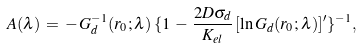<formula> <loc_0><loc_0><loc_500><loc_500>A ( \lambda ) \, = \, - \, G _ { d } ^ { - 1 } ( r _ { 0 } ; \lambda ) \, \{ 1 \, - \, \frac { 2 D \sigma _ { d } } { K _ { e l } } \, [ \ln G _ { d } ( r _ { 0 } ; \lambda ) ] ^ { \prime } \} ^ { - 1 } ,</formula> 